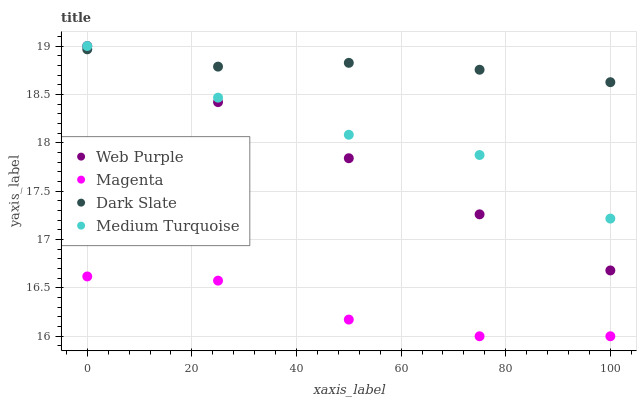Does Magenta have the minimum area under the curve?
Answer yes or no. Yes. Does Dark Slate have the maximum area under the curve?
Answer yes or no. Yes. Does Web Purple have the minimum area under the curve?
Answer yes or no. No. Does Web Purple have the maximum area under the curve?
Answer yes or no. No. Is Web Purple the smoothest?
Answer yes or no. Yes. Is Medium Turquoise the roughest?
Answer yes or no. Yes. Is Magenta the smoothest?
Answer yes or no. No. Is Magenta the roughest?
Answer yes or no. No. Does Magenta have the lowest value?
Answer yes or no. Yes. Does Web Purple have the lowest value?
Answer yes or no. No. Does Medium Turquoise have the highest value?
Answer yes or no. Yes. Does Magenta have the highest value?
Answer yes or no. No. Is Magenta less than Web Purple?
Answer yes or no. Yes. Is Dark Slate greater than Magenta?
Answer yes or no. Yes. Does Medium Turquoise intersect Dark Slate?
Answer yes or no. Yes. Is Medium Turquoise less than Dark Slate?
Answer yes or no. No. Is Medium Turquoise greater than Dark Slate?
Answer yes or no. No. Does Magenta intersect Web Purple?
Answer yes or no. No. 